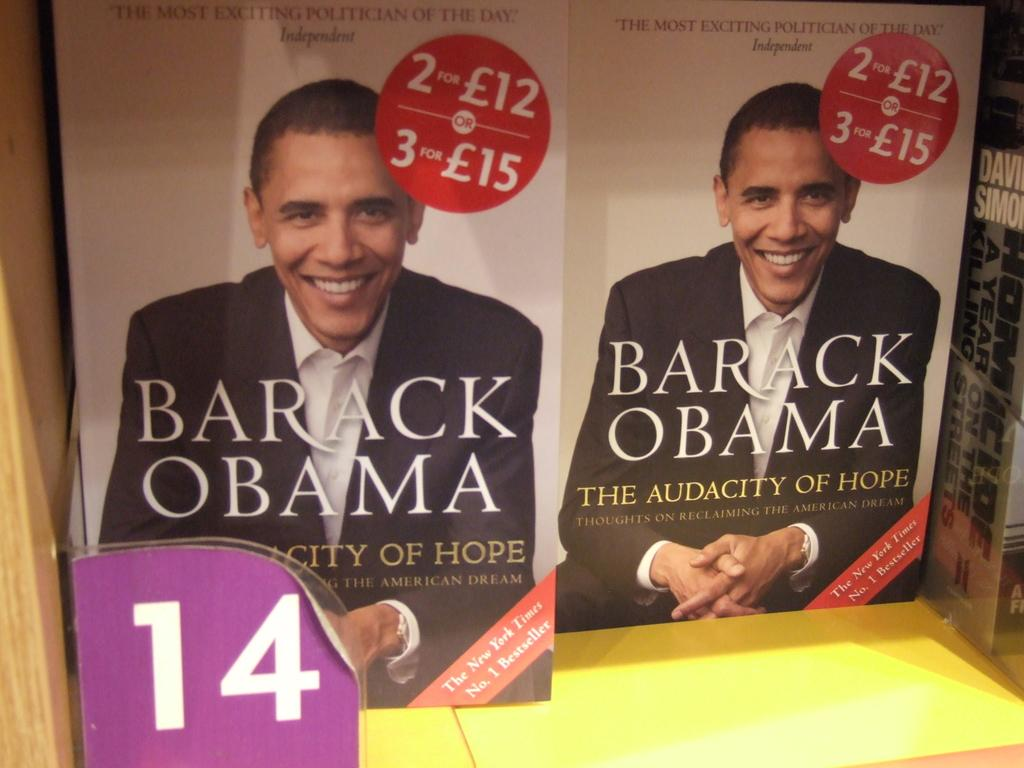<image>
Write a terse but informative summary of the picture. Two books on a shelf titled Barack Obama The Audacity of Hope Thoughts on Reclaiming the American Dream. 